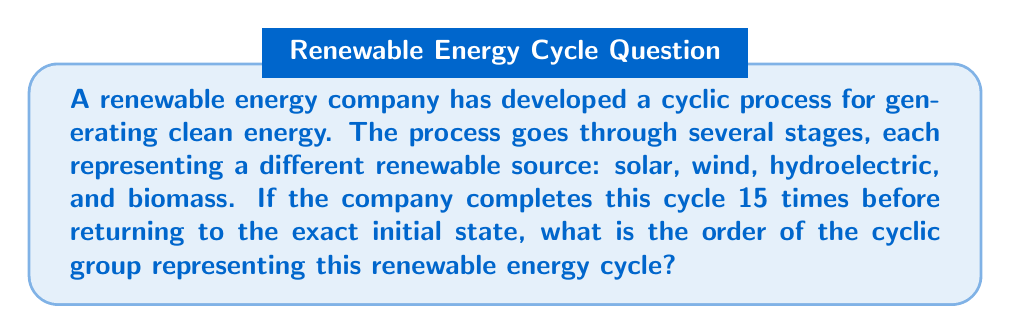Can you solve this math problem? To solve this problem, we need to understand the concept of cyclic groups and their order.

1) A cyclic group is a group that can be generated by a single element, called the generator. In this case, our generator is the complete cycle of renewable energy sources.

2) The order of a cyclic group is the smallest positive integer $n$ such that $g^n = e$, where $g$ is the generator and $e$ is the identity element.

3) In our scenario, we're told that the company needs to complete the cycle 15 times to return to the exact initial state. This means:

   $g^{15} = e$

4) However, this doesn't necessarily mean that 15 is the smallest such positive integer. We need to check if there's a smaller positive integer that satisfies this condition.

5) To do this, we need to find the factors of 15:
   $15 = 1 \times 15 = 3 \times 5$

6) We need to check if $g^3 = e$ or $g^5 = e$:

   - If $g^3 = e$, then after 3 cycles, we'd return to the initial state, which contradicts the given information.
   - Similarly, if $g^5 = e$, we'd return to the initial state after 5 cycles, which also contradicts the given information.

7) Therefore, 15 is indeed the smallest positive integer $n$ such that $g^n = e$.

Thus, the order of the cyclic group representing this renewable energy cycle is 15.
Answer: The order of the cyclic group is 15. 